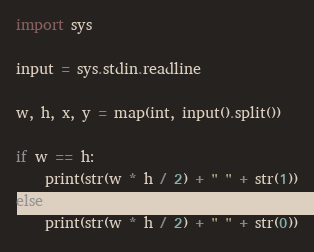<code> <loc_0><loc_0><loc_500><loc_500><_Python_>import sys

input = sys.stdin.readline

w, h, x, y = map(int, input().split())

if w == h:
    print(str(w * h / 2) + " " + str(1))
else:
    print(str(w * h / 2) + " " + str(0))
</code> 